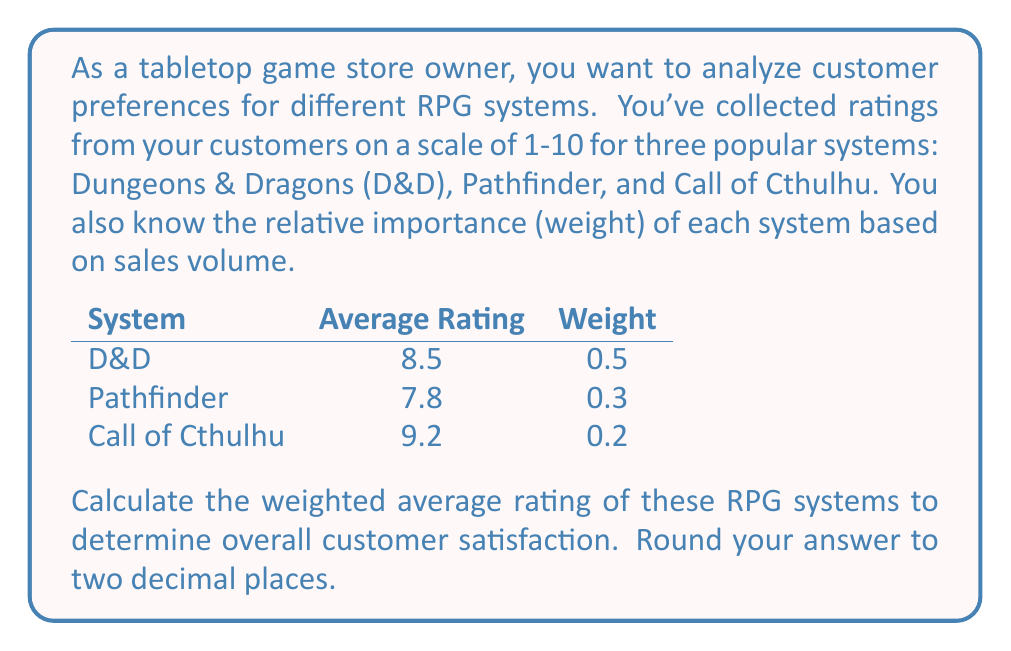Provide a solution to this math problem. To calculate the weighted average rating, we need to follow these steps:

1. Multiply each system's rating by its weight:
   D&D: $8.5 \times 0.5 = 4.25$
   Pathfinder: $7.8 \times 0.3 = 2.34$
   Call of Cthulhu: $9.2 \times 0.2 = 1.84$

2. Sum up all the weighted ratings:
   $4.25 + 2.34 + 1.84 = 8.43$

3. Verify that the sum of weights equals 1:
   $0.5 + 0.3 + 0.2 = 1$

The weighted average formula is:

$$\text{Weighted Average} = \frac{\sum_{i=1}^{n} w_i x_i}{\sum_{i=1}^{n} w_i}$$

Where $w_i$ is the weight of each item and $x_i$ is the value (rating) of each item.

In this case, since the sum of weights is 1, the denominator is 1, so our result is simply the sum of the weighted ratings:

$$\text{Weighted Average} = 8.43$$

Rounding to two decimal places gives us 8.43.
Answer: 8.43 